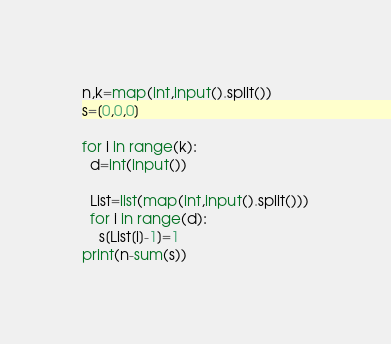<code> <loc_0><loc_0><loc_500><loc_500><_Python_>n,k=map(int,input().split())
s=[0,0,0]

for i in range(k):
  d=int(input())
 
  List=list(map(int,input().split()))
  for i in range(d):
    s[List[i]-1]=1
print(n-sum(s))
</code> 